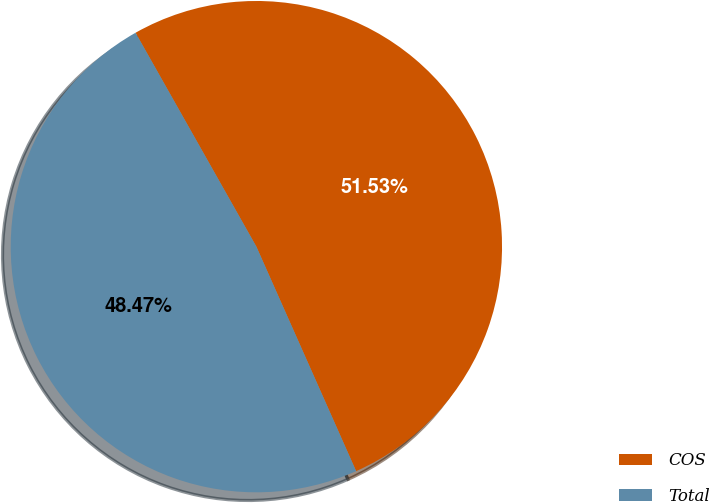Convert chart. <chart><loc_0><loc_0><loc_500><loc_500><pie_chart><fcel>COS<fcel>Total<nl><fcel>51.53%<fcel>48.47%<nl></chart> 